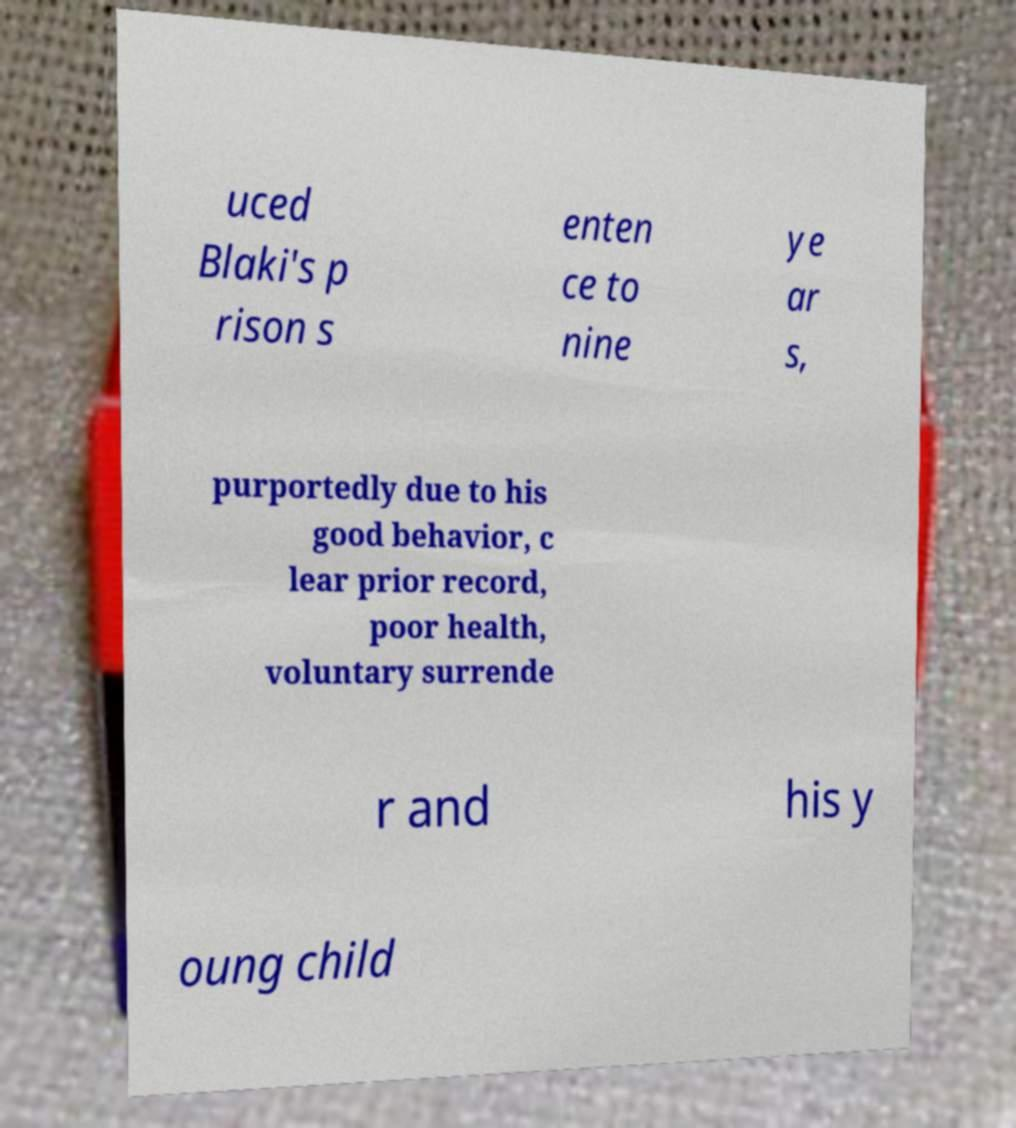There's text embedded in this image that I need extracted. Can you transcribe it verbatim? uced Blaki's p rison s enten ce to nine ye ar s, purportedly due to his good behavior, c lear prior record, poor health, voluntary surrende r and his y oung child 